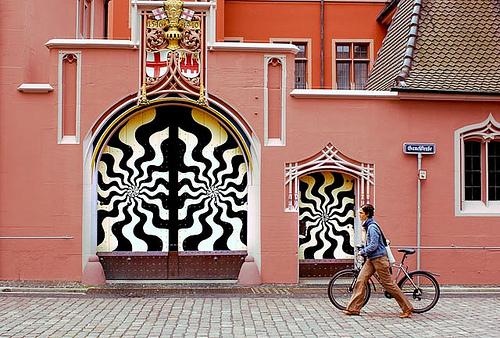Do the woman's shoes match her pants?
Write a very short answer. Yes. How many windows are in this picture?
Short answer required. 3. What is the name of the red shape on the left?
Give a very brief answer. Cross. 